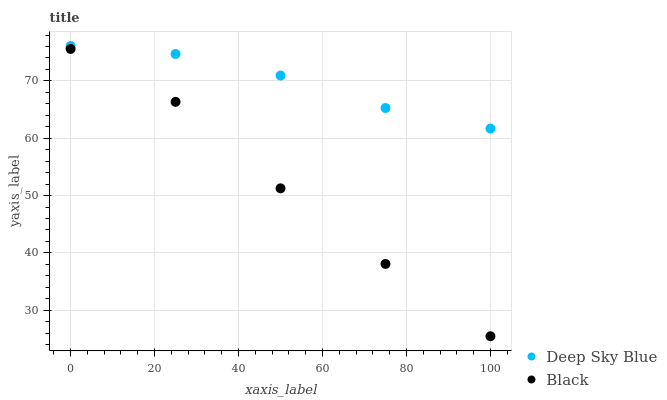Does Black have the minimum area under the curve?
Answer yes or no. Yes. Does Deep Sky Blue have the maximum area under the curve?
Answer yes or no. Yes. Does Deep Sky Blue have the minimum area under the curve?
Answer yes or no. No. Is Deep Sky Blue the smoothest?
Answer yes or no. Yes. Is Black the roughest?
Answer yes or no. Yes. Is Deep Sky Blue the roughest?
Answer yes or no. No. Does Black have the lowest value?
Answer yes or no. Yes. Does Deep Sky Blue have the lowest value?
Answer yes or no. No. Does Deep Sky Blue have the highest value?
Answer yes or no. Yes. Is Black less than Deep Sky Blue?
Answer yes or no. Yes. Is Deep Sky Blue greater than Black?
Answer yes or no. Yes. Does Black intersect Deep Sky Blue?
Answer yes or no. No. 